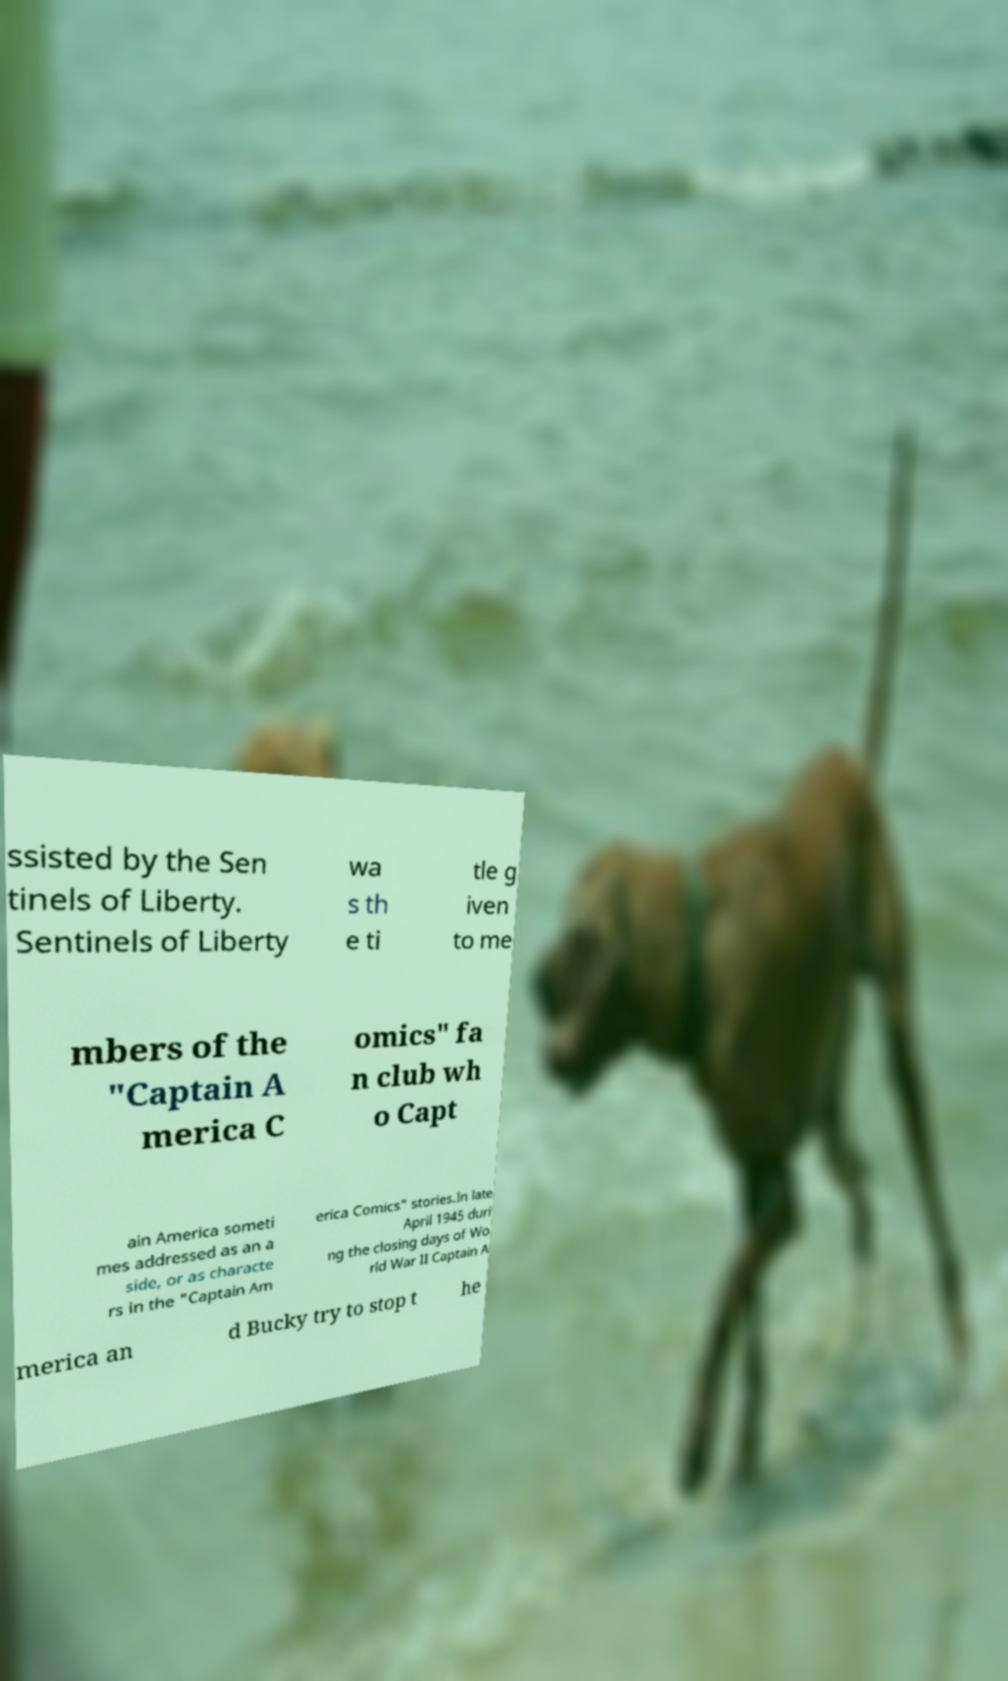What messages or text are displayed in this image? I need them in a readable, typed format. ssisted by the Sen tinels of Liberty. Sentinels of Liberty wa s th e ti tle g iven to me mbers of the "Captain A merica C omics" fa n club wh o Capt ain America someti mes addressed as an a side, or as characte rs in the "Captain Am erica Comics" stories.In late April 1945 duri ng the closing days of Wo rld War II Captain A merica an d Bucky try to stop t he 